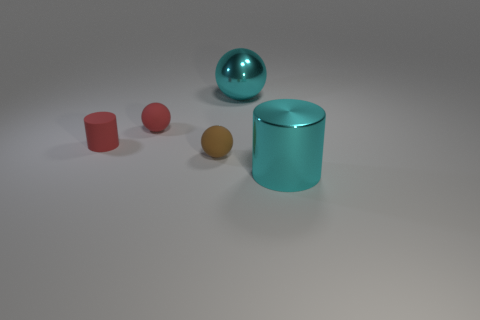What size is the red ball that is the same material as the small red cylinder?
Provide a succinct answer. Small. Are there fewer brown metallic cylinders than cyan things?
Offer a very short reply. Yes. What is the material of the large thing that is to the right of the big cyan shiny thing that is on the left side of the cyan cylinder that is right of the large ball?
Your answer should be compact. Metal. Are the big cyan thing behind the small brown rubber sphere and the small sphere behind the matte cylinder made of the same material?
Provide a succinct answer. No. How big is the ball that is behind the tiny matte cylinder and in front of the large cyan sphere?
Your answer should be very brief. Small. What is the material of the thing that is the same size as the metal cylinder?
Offer a very short reply. Metal. How many big metallic objects are in front of the cyan object behind the cyan metal thing in front of the red matte cylinder?
Offer a very short reply. 1. Is the color of the small object that is in front of the tiny rubber cylinder the same as the sphere left of the brown rubber thing?
Offer a terse response. No. What is the color of the object that is both on the left side of the big cyan shiny ball and in front of the small red matte cylinder?
Keep it short and to the point. Brown. How many other spheres have the same size as the red matte sphere?
Make the answer very short. 1. 